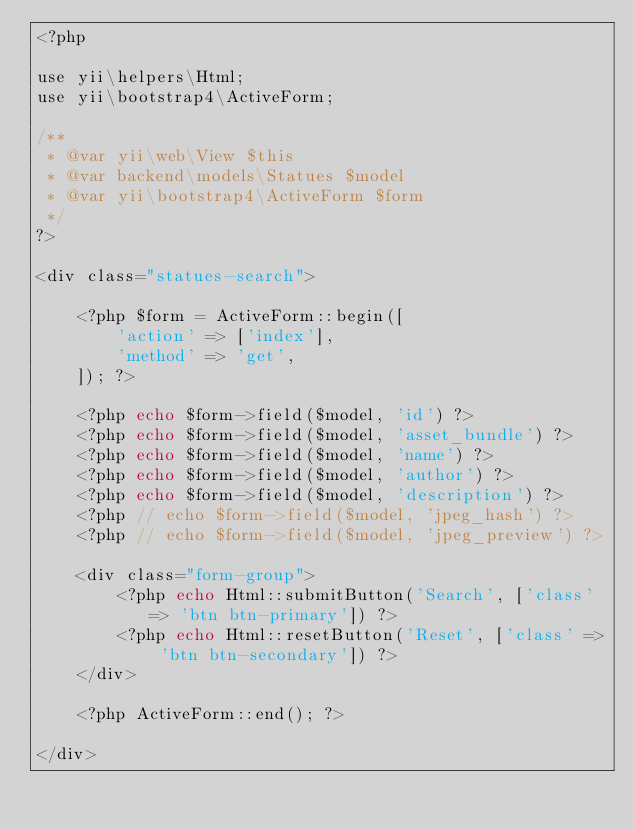<code> <loc_0><loc_0><loc_500><loc_500><_PHP_><?php

use yii\helpers\Html;
use yii\bootstrap4\ActiveForm;

/**
 * @var yii\web\View $this
 * @var backend\models\Statues $model
 * @var yii\bootstrap4\ActiveForm $form
 */
?>

<div class="statues-search">

    <?php $form = ActiveForm::begin([
        'action' => ['index'],
        'method' => 'get',
    ]); ?>

    <?php echo $form->field($model, 'id') ?>
    <?php echo $form->field($model, 'asset_bundle') ?>
    <?php echo $form->field($model, 'name') ?>
    <?php echo $form->field($model, 'author') ?>
    <?php echo $form->field($model, 'description') ?>
    <?php // echo $form->field($model, 'jpeg_hash') ?>
    <?php // echo $form->field($model, 'jpeg_preview') ?>

    <div class="form-group">
        <?php echo Html::submitButton('Search', ['class' => 'btn btn-primary']) ?>
        <?php echo Html::resetButton('Reset', ['class' => 'btn btn-secondary']) ?>
    </div>

    <?php ActiveForm::end(); ?>

</div>
</code> 